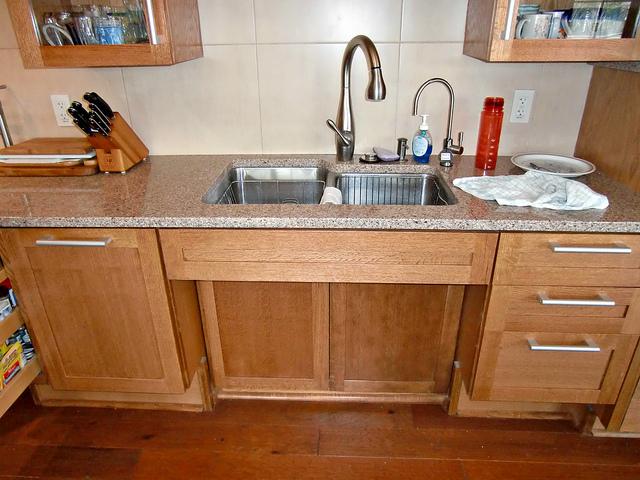Is the counter clear?
Give a very brief answer. No. What color is the bottle on the counter?
Short answer required. Red. What color is the dish towel?
Concise answer only. White. 